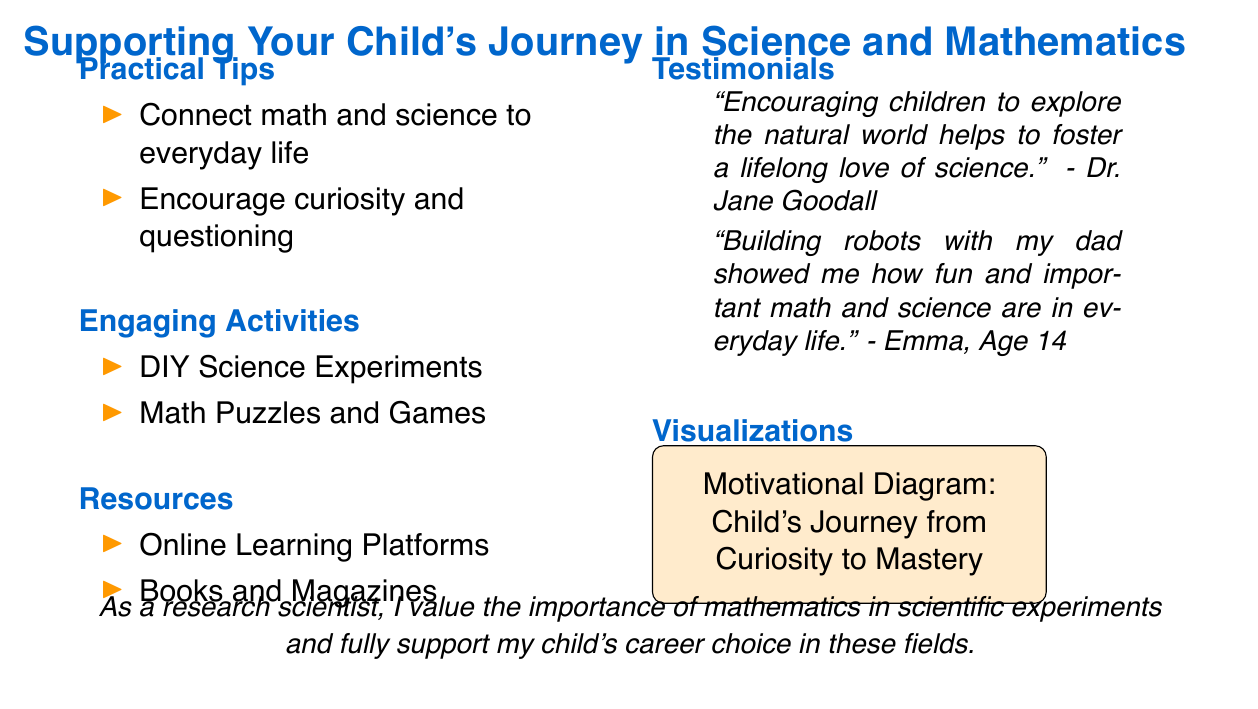What are two practical tips for supporting a child's journey in science and mathematics? The slide lists two practical tips under the "Practical Tips" section, which are connecting math and science to everyday life and encouraging curiosity and questioning.
Answer: Connect math and science to everyday life, encourage curiosity and questioning What engaging activity involves hands-on experimentation? The slide mentions DIY Science Experiments as one of the engaging activities that parents can do with their children.
Answer: DIY Science Experiments What resource type is suggested for children's learning? The slide suggests two types of resources, with one being online learning platforms as a means for supporting a child's education in science and mathematics.
Answer: Online Learning Platforms Who made a testimonial related to fostering a love of science? The slide includes a quote from Dr. Jane Goodall about nurturing children's exploration of the natural world to foster a love of science.
Answer: Dr. Jane Goodall What is the age of the child who provided a testimonial about building robots? According to the slide, Emma, who provided a testimonial about building robots, is 14 years old.
Answer: 14 What is depicted in the motivational diagram on the slide? The motivational diagram on the slide visually represents the Child's Journey from Curiosity to Mastery, summarizing a key message of support in the scientific journey.
Answer: Child's Journey from Curiosity to Mastery What color is used for the main headings in the presentation? The slide identifies "maincolor" in the document, which is set to an RGB color value of 0, 102, 204 and is used for the main headings.
Answer: maincolor What is the overall theme of the presentation slide? The presentation slide focuses on supporting a child's journey in science and mathematics, highlighting practical tips, engaging activities, resources, testimonials, and visualizations.
Answer: Supporting Your Child's Journey in Science and Mathematics 